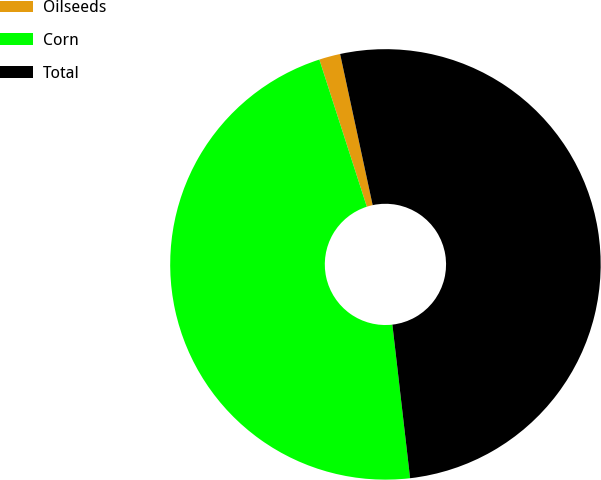Convert chart. <chart><loc_0><loc_0><loc_500><loc_500><pie_chart><fcel>Oilseeds<fcel>Corn<fcel>Total<nl><fcel>1.59%<fcel>46.86%<fcel>51.55%<nl></chart> 